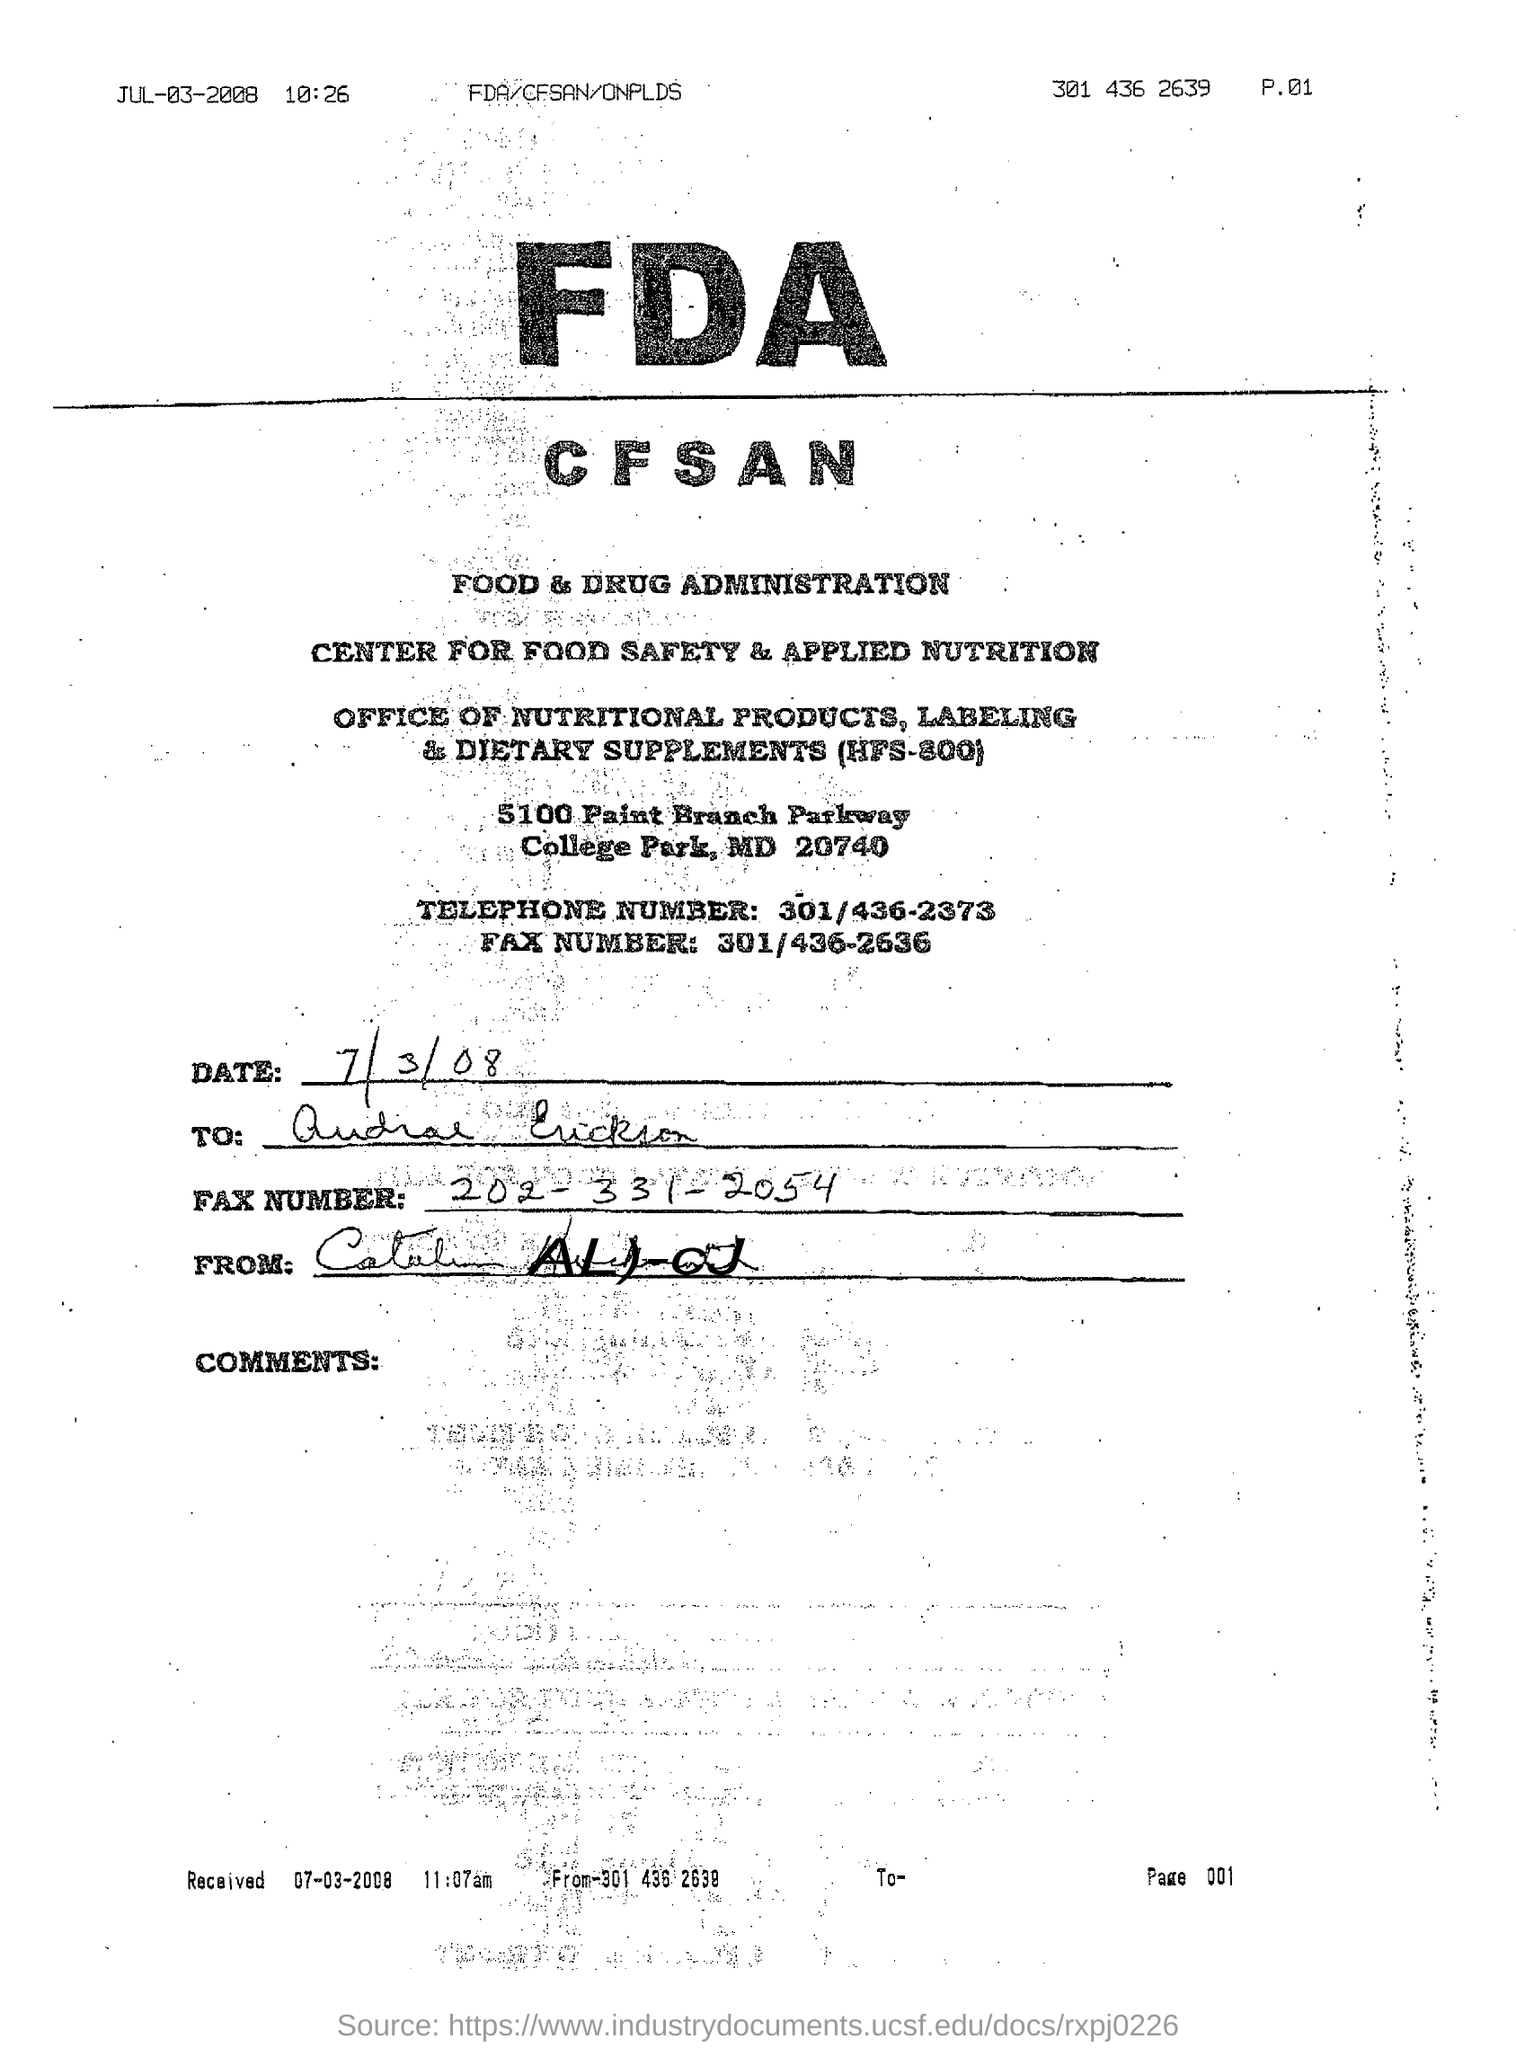Highlight a few significant elements in this photo. The full form of FDA is the Food and Drug Administration. The telephone number given is 301/436-2373. 